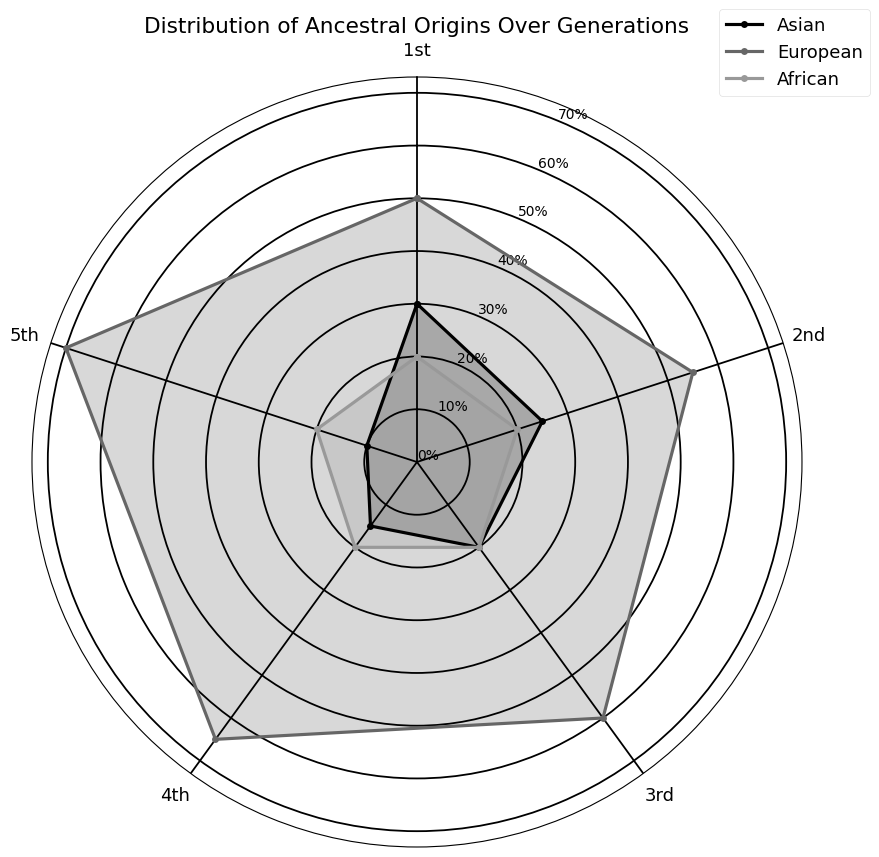what percentage of our ancestors in the 3rd generation are Asian? In the figure, find the segment that represents the 3rd generation and identify the percentage for the Asian origin.
Answer: 20% Which generation shows the highest percentage of European ancestry? In the figure, review each generation and their respective percentage of European ancestry. The highest is for the 5th generation.
Answer: 5th generation Does the percentage of African ancestry change over the generations? Examine the percentage values for African ancestry in each generation on the figure. Since all the values remain 20%, they do not change.
Answer: No Compare the Asian ancestry in the 1st and 5th generations. Which one is higher? Look at the percentages of Asian ancestry in both the 1st (30%) and 5th (10%) generations and compare them. The 1st is higher.
Answer: 1st generation What is the trend for European ancestry over the generations? Observe the percentages for European ancestry from the 1st to the 5th generation. It consistently increases with each subsequent generation.
Answer: Increasing trend Calculate the average percentage of African ancestry over all generations. Add the percentages for African ancestry across all generations and divide by the number of generations (20% * 5 = 100%, 100% / 5 = 20%).
Answer: 20% Which ancestral origin has the smallest percentage in the 4th generation? Identify the smallest percentage among the ancestral origins in the 4th generation by comparing Asian (15%), European (65%), and African (20%). Asian is the smallest.
Answer: Asian What is the difference in European ancestry percentage between the 2nd and 3rd generations? Subtract the percentage of European ancestry in the 2nd generation (55%) from that in the 3rd generation (60%). The difference is 5%.
Answer: 5% List the ancestral origins in the 1st generation in descending order of their percentages. Order the percentages of Asian (30%), European (50%), and African (20%) ancestries in the 1st generation from highest to lowest.
Answer: European, Asian, African Is the percentage of Asian ancestry higher in the 2nd generation or the 4th generation? Compare the Asian ancestry percentages in the 2nd generation (25%) and the 4th generation (15%). The 2nd generation is higher.
Answer: 2nd generation 